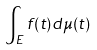<formula> <loc_0><loc_0><loc_500><loc_500>\int _ { E } f ( t ) d \mu ( t )</formula> 